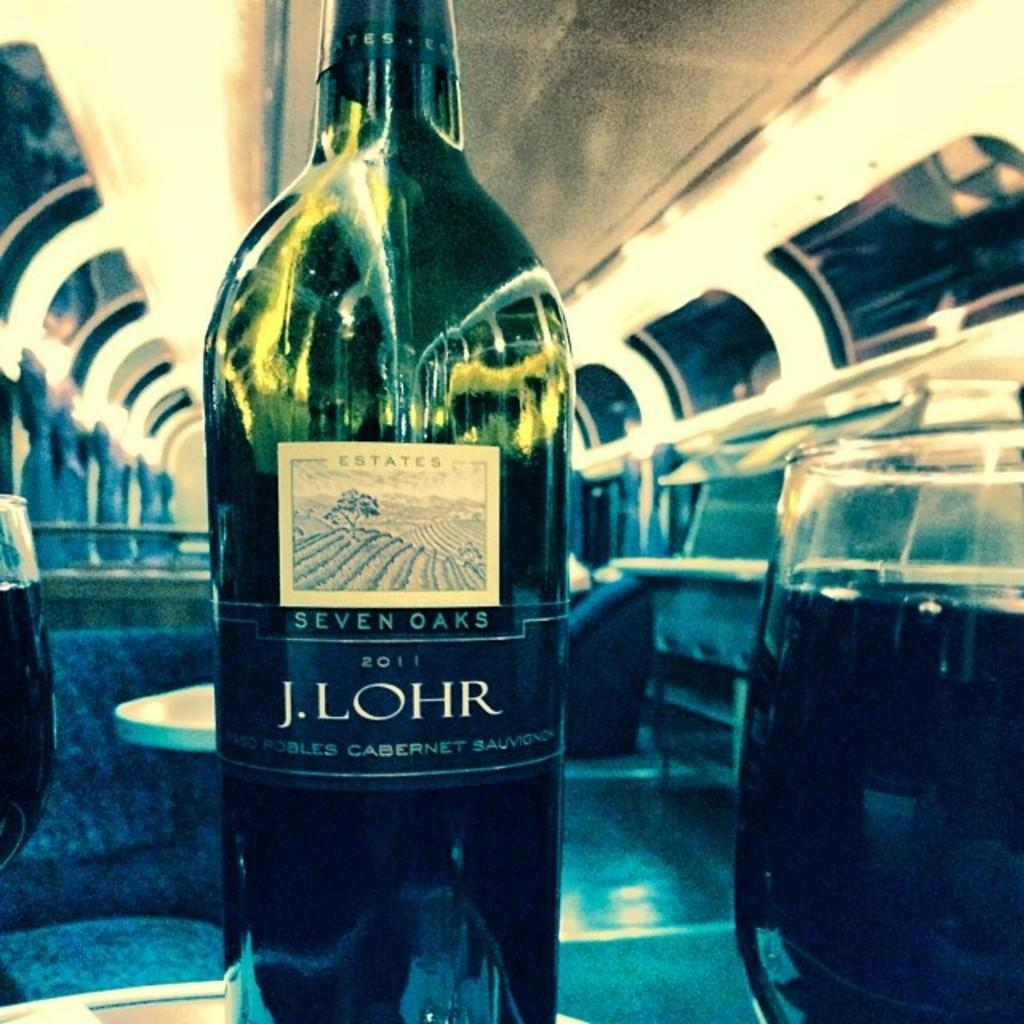<image>
Write a terse but informative summary of the picture. a bottle of 2011 J.Lohr steven oaks wine on a small table 